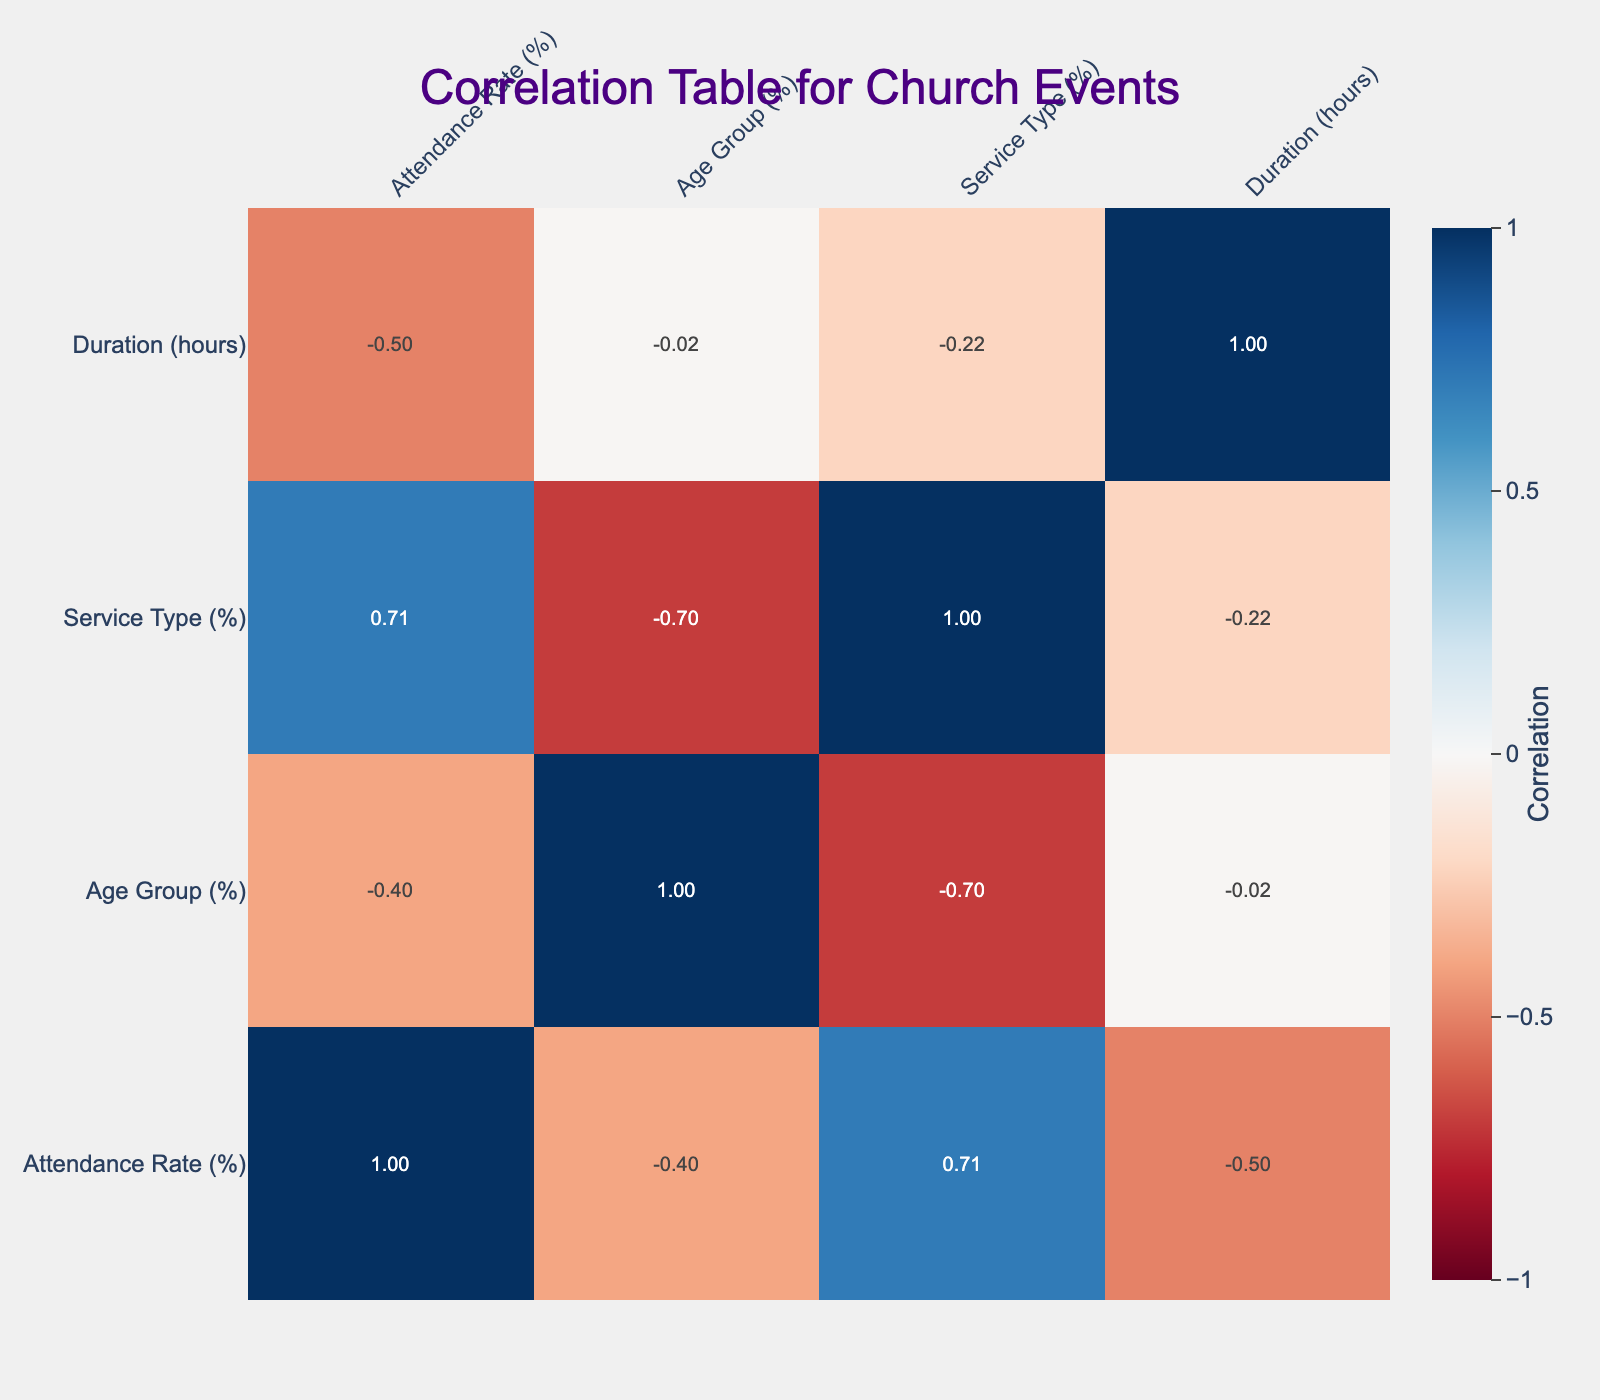What is the attendance rate for the Sunday Service? The Sunday Service has an attendance rate of 75%, which can be directly read from the table under the Attendance Rate column for the corresponding event.
Answer: 75% Which event has the lowest attendance rate? Upon reviewing the Attendance Rate column, the Charity Fundraiser has the lowest attendance rate of 25%, making it the event with the least participation.
Answer: 25% What is the average attendance rate of events that last for 2 hours? The events lasting 2 hours are Midweek Bible Study (40%), Choir Practice (60%), Prayer Meeting (55%), and Senior Fellowship (45%). Summing these values gives 40 + 60 + 55 + 45 = 200. Dividing by the number of events (4) results in an average of 200 / 4 = 50%.
Answer: 50% Is the attendance rate for Community Potluck greater than 40%? The Community Potluck has an attendance rate of 50%, which is indeed greater than 40%. This can be verified by comparing the specific attendance rate in the table.
Answer: Yes Which event has the highest correlation with the Age Group percentage? To determine which event correlates most with Age Group percentage, we look at the correlation values in the correlation table. The event with the highest correlation with Age Group is the Senior Fellowship, with a correlation coefficient of 1.0, indicating a perfect positive correlation.
Answer: Senior Fellowship How does the attendance rate for Choir Practice compare to Youth Group Meeting? The Choir Practice has an attendance rate of 60%, while the Youth Group Meeting has an attendance rate of 30%. Comparing these values shows that the attendance rate for Choir Practice is significantly higher than that of Youth Group Meeting.
Answer: Higher Is the Prayer Meeting’s attendance rate less than the Social Potluck? The Prayer Meeting has an attendance rate of 55%, and the Community Potluck has an attendance rate of 50%. Since 55 is greater than 50, the Prayer Meeting's attendance is not less than that of the Community Potluck.
Answer: No What is the difference in attendance rates between the Holiday Service and the Choir Practice? The Holiday Service has an attendance rate of 80%, while the Choir Practice has an attendance rate of 60%. To find the difference, we subtract: 80 - 60 = 20%. Thus, there is a 20% difference between the two events.
Answer: 20% What is the average duration of the events with attendance rate greater than 50%? Events with attendance rates above 50% are Sunday Service (1.5 hours), Choir Practice (2 hours), Holiday Service (1.5 hours), and Prayer Meeting (1 hour). Therefore, their durations are 1.5 + 2 + 1.5 + 1 = 6 hours. Dividing by four gives an average duration of 6 / 4 = 1.5 hours.
Answer: 1.5 hours 